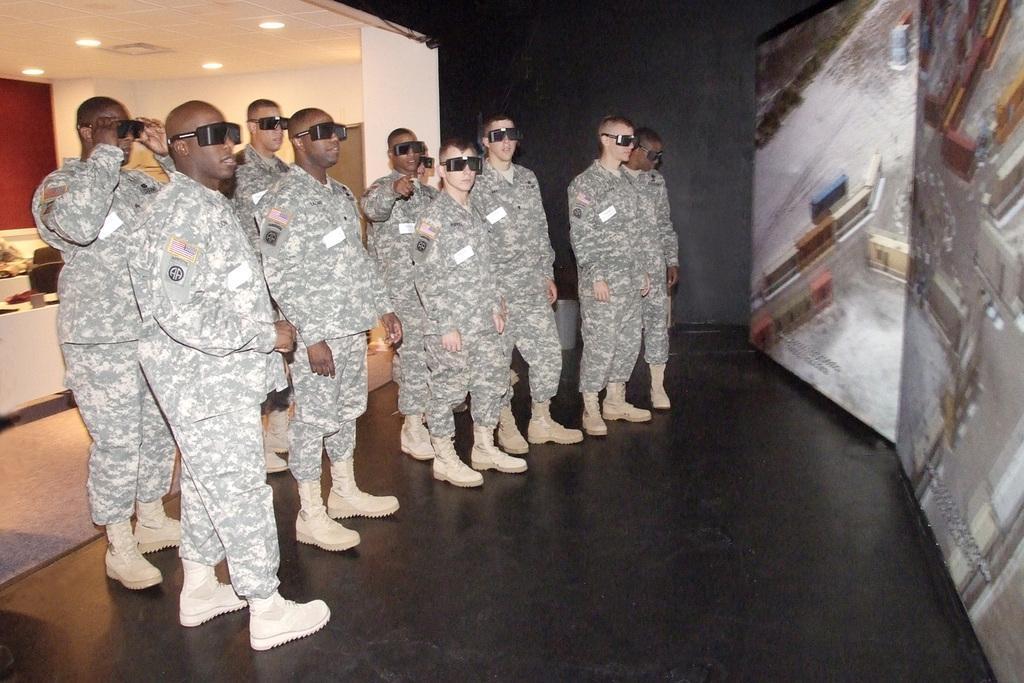Please provide a concise description of this image. On the left side a group of Army men wore dresses, shoes, goggles and looking at the right side. On the left side there are ceiling lights. 